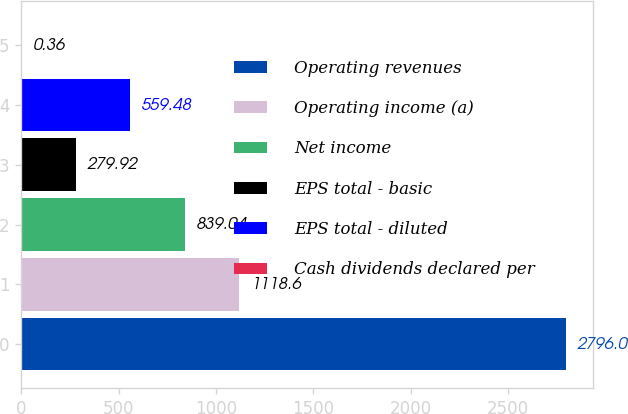<chart> <loc_0><loc_0><loc_500><loc_500><bar_chart><fcel>Operating revenues<fcel>Operating income (a)<fcel>Net income<fcel>EPS total - basic<fcel>EPS total - diluted<fcel>Cash dividends declared per<nl><fcel>2796<fcel>1118.6<fcel>839.04<fcel>279.92<fcel>559.48<fcel>0.36<nl></chart> 